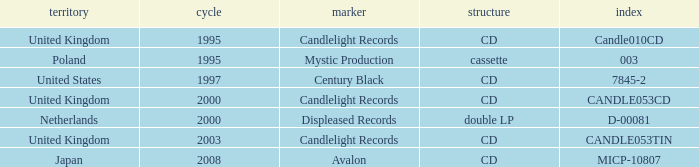What is Candlelight Records format? CD, CD, CD. 